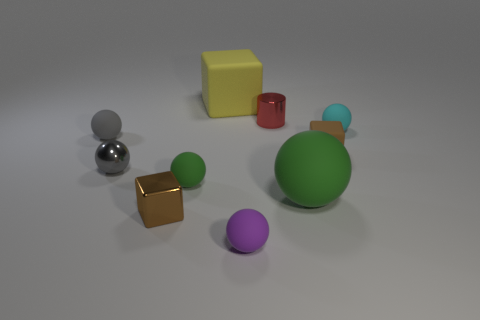Are there fewer large yellow rubber blocks that are in front of the gray rubber thing than large rubber cubes that are left of the tiny metallic block?
Keep it short and to the point. No. There is a object that is the same color as the large sphere; what is its shape?
Your response must be concise. Sphere. What number of yellow cubes are the same size as the yellow thing?
Your response must be concise. 0. Are the large object that is behind the small red shiny cylinder and the tiny green sphere made of the same material?
Ensure brevity in your answer.  Yes. Is there a small green shiny thing?
Your answer should be very brief. No. What size is the other purple ball that is made of the same material as the big sphere?
Your response must be concise. Small. Is there a small object of the same color as the small matte cube?
Keep it short and to the point. Yes. Do the large object on the left side of the red cylinder and the shiny thing that is right of the tiny purple thing have the same color?
Provide a short and direct response. No. The other block that is the same color as the small rubber cube is what size?
Offer a very short reply. Small. Is there a purple block made of the same material as the tiny red object?
Make the answer very short. No. 